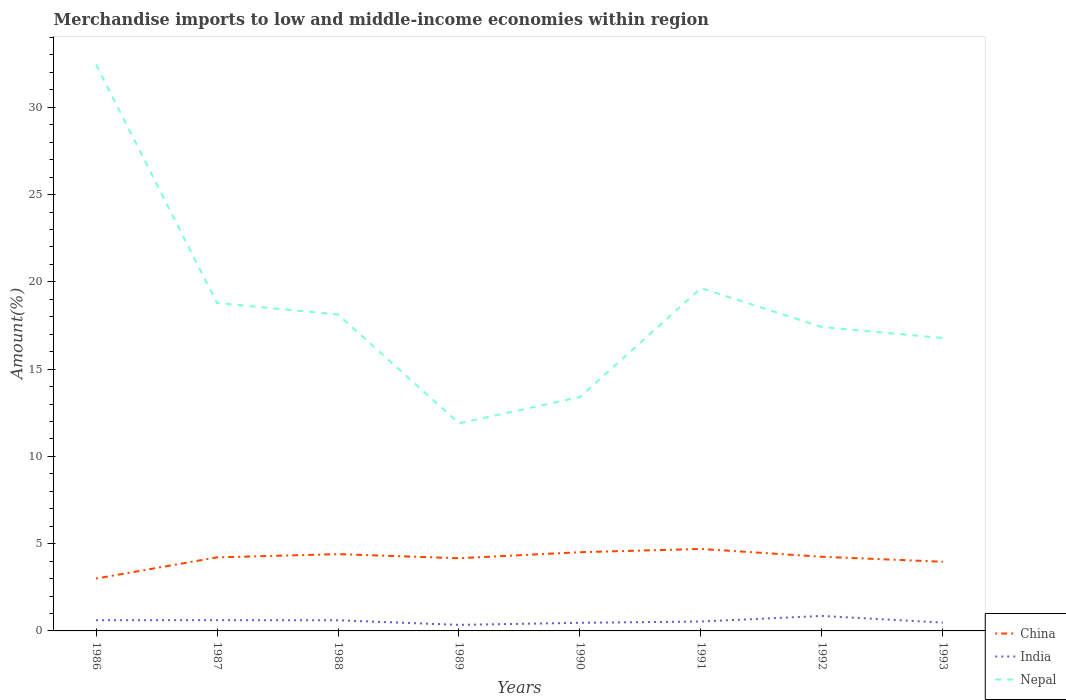Across all years, what is the maximum percentage of amount earned from merchandise imports in China?
Offer a very short reply. 3. What is the total percentage of amount earned from merchandise imports in India in the graph?
Provide a short and direct response. -0. What is the difference between the highest and the second highest percentage of amount earned from merchandise imports in China?
Make the answer very short. 1.7. What is the difference between the highest and the lowest percentage of amount earned from merchandise imports in India?
Offer a terse response. 4. How many years are there in the graph?
Your response must be concise. 8. Are the values on the major ticks of Y-axis written in scientific E-notation?
Ensure brevity in your answer.  No. What is the title of the graph?
Your response must be concise. Merchandise imports to low and middle-income economies within region. What is the label or title of the X-axis?
Your answer should be compact. Years. What is the label or title of the Y-axis?
Make the answer very short. Amount(%). What is the Amount(%) in China in 1986?
Offer a terse response. 3. What is the Amount(%) in India in 1986?
Keep it short and to the point. 0.61. What is the Amount(%) in Nepal in 1986?
Ensure brevity in your answer.  32.45. What is the Amount(%) in China in 1987?
Provide a succinct answer. 4.21. What is the Amount(%) of India in 1987?
Ensure brevity in your answer.  0.62. What is the Amount(%) in Nepal in 1987?
Your response must be concise. 18.79. What is the Amount(%) of China in 1988?
Your answer should be very brief. 4.4. What is the Amount(%) in India in 1988?
Offer a very short reply. 0.61. What is the Amount(%) in Nepal in 1988?
Give a very brief answer. 18.13. What is the Amount(%) in China in 1989?
Your answer should be compact. 4.16. What is the Amount(%) of India in 1989?
Make the answer very short. 0.35. What is the Amount(%) of Nepal in 1989?
Your answer should be very brief. 11.89. What is the Amount(%) in China in 1990?
Keep it short and to the point. 4.51. What is the Amount(%) in India in 1990?
Your answer should be very brief. 0.46. What is the Amount(%) of Nepal in 1990?
Give a very brief answer. 13.4. What is the Amount(%) of China in 1991?
Offer a terse response. 4.7. What is the Amount(%) of India in 1991?
Your answer should be very brief. 0.54. What is the Amount(%) of Nepal in 1991?
Offer a terse response. 19.64. What is the Amount(%) in China in 1992?
Ensure brevity in your answer.  4.25. What is the Amount(%) of India in 1992?
Make the answer very short. 0.86. What is the Amount(%) of Nepal in 1992?
Your answer should be compact. 17.41. What is the Amount(%) in China in 1993?
Your answer should be compact. 3.96. What is the Amount(%) of India in 1993?
Make the answer very short. 0.48. What is the Amount(%) of Nepal in 1993?
Your answer should be compact. 16.78. Across all years, what is the maximum Amount(%) of China?
Offer a terse response. 4.7. Across all years, what is the maximum Amount(%) in India?
Provide a short and direct response. 0.86. Across all years, what is the maximum Amount(%) of Nepal?
Make the answer very short. 32.45. Across all years, what is the minimum Amount(%) of China?
Provide a succinct answer. 3. Across all years, what is the minimum Amount(%) of India?
Give a very brief answer. 0.35. Across all years, what is the minimum Amount(%) of Nepal?
Ensure brevity in your answer.  11.89. What is the total Amount(%) in China in the graph?
Provide a short and direct response. 33.2. What is the total Amount(%) in India in the graph?
Offer a terse response. 4.52. What is the total Amount(%) in Nepal in the graph?
Your answer should be very brief. 148.49. What is the difference between the Amount(%) of China in 1986 and that in 1987?
Your answer should be very brief. -1.21. What is the difference between the Amount(%) in India in 1986 and that in 1987?
Provide a succinct answer. -0. What is the difference between the Amount(%) of Nepal in 1986 and that in 1987?
Your answer should be very brief. 13.66. What is the difference between the Amount(%) in China in 1986 and that in 1988?
Ensure brevity in your answer.  -1.4. What is the difference between the Amount(%) of India in 1986 and that in 1988?
Provide a succinct answer. 0.01. What is the difference between the Amount(%) in Nepal in 1986 and that in 1988?
Ensure brevity in your answer.  14.32. What is the difference between the Amount(%) of China in 1986 and that in 1989?
Offer a very short reply. -1.16. What is the difference between the Amount(%) of India in 1986 and that in 1989?
Your answer should be compact. 0.27. What is the difference between the Amount(%) in Nepal in 1986 and that in 1989?
Make the answer very short. 20.55. What is the difference between the Amount(%) of China in 1986 and that in 1990?
Offer a very short reply. -1.51. What is the difference between the Amount(%) in India in 1986 and that in 1990?
Keep it short and to the point. 0.15. What is the difference between the Amount(%) of Nepal in 1986 and that in 1990?
Give a very brief answer. 19.04. What is the difference between the Amount(%) in China in 1986 and that in 1991?
Your answer should be compact. -1.7. What is the difference between the Amount(%) in India in 1986 and that in 1991?
Keep it short and to the point. 0.07. What is the difference between the Amount(%) in Nepal in 1986 and that in 1991?
Keep it short and to the point. 12.81. What is the difference between the Amount(%) of China in 1986 and that in 1992?
Provide a short and direct response. -1.25. What is the difference between the Amount(%) in India in 1986 and that in 1992?
Give a very brief answer. -0.25. What is the difference between the Amount(%) in Nepal in 1986 and that in 1992?
Ensure brevity in your answer.  15.04. What is the difference between the Amount(%) in China in 1986 and that in 1993?
Offer a very short reply. -0.96. What is the difference between the Amount(%) in India in 1986 and that in 1993?
Ensure brevity in your answer.  0.14. What is the difference between the Amount(%) in Nepal in 1986 and that in 1993?
Offer a very short reply. 15.66. What is the difference between the Amount(%) of China in 1987 and that in 1988?
Your response must be concise. -0.19. What is the difference between the Amount(%) in India in 1987 and that in 1988?
Provide a short and direct response. 0.01. What is the difference between the Amount(%) in Nepal in 1987 and that in 1988?
Offer a very short reply. 0.66. What is the difference between the Amount(%) of China in 1987 and that in 1989?
Offer a very short reply. 0.05. What is the difference between the Amount(%) in India in 1987 and that in 1989?
Provide a short and direct response. 0.27. What is the difference between the Amount(%) of Nepal in 1987 and that in 1989?
Provide a short and direct response. 6.89. What is the difference between the Amount(%) in China in 1987 and that in 1990?
Keep it short and to the point. -0.3. What is the difference between the Amount(%) in India in 1987 and that in 1990?
Ensure brevity in your answer.  0.15. What is the difference between the Amount(%) in Nepal in 1987 and that in 1990?
Your answer should be compact. 5.39. What is the difference between the Amount(%) of China in 1987 and that in 1991?
Offer a very short reply. -0.48. What is the difference between the Amount(%) of India in 1987 and that in 1991?
Your answer should be compact. 0.08. What is the difference between the Amount(%) of Nepal in 1987 and that in 1991?
Your response must be concise. -0.85. What is the difference between the Amount(%) of China in 1987 and that in 1992?
Ensure brevity in your answer.  -0.04. What is the difference between the Amount(%) in India in 1987 and that in 1992?
Offer a terse response. -0.24. What is the difference between the Amount(%) in Nepal in 1987 and that in 1992?
Your answer should be compact. 1.38. What is the difference between the Amount(%) of China in 1987 and that in 1993?
Your answer should be very brief. 0.25. What is the difference between the Amount(%) in India in 1987 and that in 1993?
Your answer should be very brief. 0.14. What is the difference between the Amount(%) of Nepal in 1987 and that in 1993?
Ensure brevity in your answer.  2.01. What is the difference between the Amount(%) of China in 1988 and that in 1989?
Your answer should be very brief. 0.23. What is the difference between the Amount(%) in India in 1988 and that in 1989?
Offer a very short reply. 0.26. What is the difference between the Amount(%) of Nepal in 1988 and that in 1989?
Ensure brevity in your answer.  6.23. What is the difference between the Amount(%) of China in 1988 and that in 1990?
Offer a very short reply. -0.11. What is the difference between the Amount(%) of India in 1988 and that in 1990?
Give a very brief answer. 0.14. What is the difference between the Amount(%) of Nepal in 1988 and that in 1990?
Ensure brevity in your answer.  4.73. What is the difference between the Amount(%) of China in 1988 and that in 1991?
Keep it short and to the point. -0.3. What is the difference between the Amount(%) in India in 1988 and that in 1991?
Make the answer very short. 0.07. What is the difference between the Amount(%) of Nepal in 1988 and that in 1991?
Provide a succinct answer. -1.51. What is the difference between the Amount(%) in China in 1988 and that in 1992?
Your response must be concise. 0.15. What is the difference between the Amount(%) in India in 1988 and that in 1992?
Give a very brief answer. -0.25. What is the difference between the Amount(%) in Nepal in 1988 and that in 1992?
Offer a very short reply. 0.72. What is the difference between the Amount(%) of China in 1988 and that in 1993?
Your answer should be compact. 0.44. What is the difference between the Amount(%) in India in 1988 and that in 1993?
Make the answer very short. 0.13. What is the difference between the Amount(%) in Nepal in 1988 and that in 1993?
Ensure brevity in your answer.  1.35. What is the difference between the Amount(%) of China in 1989 and that in 1990?
Offer a terse response. -0.35. What is the difference between the Amount(%) in India in 1989 and that in 1990?
Provide a short and direct response. -0.12. What is the difference between the Amount(%) in Nepal in 1989 and that in 1990?
Your response must be concise. -1.51. What is the difference between the Amount(%) in China in 1989 and that in 1991?
Make the answer very short. -0.53. What is the difference between the Amount(%) in India in 1989 and that in 1991?
Give a very brief answer. -0.19. What is the difference between the Amount(%) in Nepal in 1989 and that in 1991?
Offer a terse response. -7.75. What is the difference between the Amount(%) of China in 1989 and that in 1992?
Your answer should be compact. -0.09. What is the difference between the Amount(%) in India in 1989 and that in 1992?
Provide a short and direct response. -0.51. What is the difference between the Amount(%) of Nepal in 1989 and that in 1992?
Give a very brief answer. -5.52. What is the difference between the Amount(%) in China in 1989 and that in 1993?
Ensure brevity in your answer.  0.2. What is the difference between the Amount(%) in India in 1989 and that in 1993?
Keep it short and to the point. -0.13. What is the difference between the Amount(%) of Nepal in 1989 and that in 1993?
Your answer should be compact. -4.89. What is the difference between the Amount(%) in China in 1990 and that in 1991?
Your answer should be very brief. -0.19. What is the difference between the Amount(%) in India in 1990 and that in 1991?
Provide a short and direct response. -0.08. What is the difference between the Amount(%) in Nepal in 1990 and that in 1991?
Make the answer very short. -6.24. What is the difference between the Amount(%) in China in 1990 and that in 1992?
Provide a succinct answer. 0.26. What is the difference between the Amount(%) of India in 1990 and that in 1992?
Ensure brevity in your answer.  -0.39. What is the difference between the Amount(%) of Nepal in 1990 and that in 1992?
Your response must be concise. -4.01. What is the difference between the Amount(%) of China in 1990 and that in 1993?
Provide a succinct answer. 0.55. What is the difference between the Amount(%) of India in 1990 and that in 1993?
Offer a terse response. -0.01. What is the difference between the Amount(%) in Nepal in 1990 and that in 1993?
Your answer should be compact. -3.38. What is the difference between the Amount(%) in China in 1991 and that in 1992?
Give a very brief answer. 0.45. What is the difference between the Amount(%) in India in 1991 and that in 1992?
Your answer should be very brief. -0.32. What is the difference between the Amount(%) of Nepal in 1991 and that in 1992?
Provide a short and direct response. 2.23. What is the difference between the Amount(%) in China in 1991 and that in 1993?
Make the answer very short. 0.73. What is the difference between the Amount(%) in India in 1991 and that in 1993?
Your answer should be very brief. 0.06. What is the difference between the Amount(%) in Nepal in 1991 and that in 1993?
Your answer should be very brief. 2.86. What is the difference between the Amount(%) of China in 1992 and that in 1993?
Provide a short and direct response. 0.29. What is the difference between the Amount(%) of India in 1992 and that in 1993?
Make the answer very short. 0.38. What is the difference between the Amount(%) in Nepal in 1992 and that in 1993?
Your answer should be very brief. 0.63. What is the difference between the Amount(%) of China in 1986 and the Amount(%) of India in 1987?
Offer a terse response. 2.39. What is the difference between the Amount(%) in China in 1986 and the Amount(%) in Nepal in 1987?
Your answer should be compact. -15.79. What is the difference between the Amount(%) of India in 1986 and the Amount(%) of Nepal in 1987?
Offer a very short reply. -18.17. What is the difference between the Amount(%) of China in 1986 and the Amount(%) of India in 1988?
Offer a very short reply. 2.39. What is the difference between the Amount(%) in China in 1986 and the Amount(%) in Nepal in 1988?
Keep it short and to the point. -15.13. What is the difference between the Amount(%) in India in 1986 and the Amount(%) in Nepal in 1988?
Your answer should be compact. -17.51. What is the difference between the Amount(%) in China in 1986 and the Amount(%) in India in 1989?
Provide a succinct answer. 2.65. What is the difference between the Amount(%) of China in 1986 and the Amount(%) of Nepal in 1989?
Make the answer very short. -8.89. What is the difference between the Amount(%) of India in 1986 and the Amount(%) of Nepal in 1989?
Your response must be concise. -11.28. What is the difference between the Amount(%) in China in 1986 and the Amount(%) in India in 1990?
Your response must be concise. 2.54. What is the difference between the Amount(%) in China in 1986 and the Amount(%) in Nepal in 1990?
Give a very brief answer. -10.4. What is the difference between the Amount(%) in India in 1986 and the Amount(%) in Nepal in 1990?
Your answer should be very brief. -12.79. What is the difference between the Amount(%) in China in 1986 and the Amount(%) in India in 1991?
Give a very brief answer. 2.46. What is the difference between the Amount(%) in China in 1986 and the Amount(%) in Nepal in 1991?
Your response must be concise. -16.64. What is the difference between the Amount(%) of India in 1986 and the Amount(%) of Nepal in 1991?
Provide a succinct answer. -19.03. What is the difference between the Amount(%) of China in 1986 and the Amount(%) of India in 1992?
Give a very brief answer. 2.14. What is the difference between the Amount(%) in China in 1986 and the Amount(%) in Nepal in 1992?
Offer a very short reply. -14.41. What is the difference between the Amount(%) of India in 1986 and the Amount(%) of Nepal in 1992?
Offer a terse response. -16.8. What is the difference between the Amount(%) in China in 1986 and the Amount(%) in India in 1993?
Your response must be concise. 2.52. What is the difference between the Amount(%) in China in 1986 and the Amount(%) in Nepal in 1993?
Offer a very short reply. -13.78. What is the difference between the Amount(%) in India in 1986 and the Amount(%) in Nepal in 1993?
Provide a short and direct response. -16.17. What is the difference between the Amount(%) in China in 1987 and the Amount(%) in India in 1988?
Offer a very short reply. 3.61. What is the difference between the Amount(%) of China in 1987 and the Amount(%) of Nepal in 1988?
Provide a succinct answer. -13.91. What is the difference between the Amount(%) of India in 1987 and the Amount(%) of Nepal in 1988?
Keep it short and to the point. -17.51. What is the difference between the Amount(%) in China in 1987 and the Amount(%) in India in 1989?
Give a very brief answer. 3.87. What is the difference between the Amount(%) in China in 1987 and the Amount(%) in Nepal in 1989?
Make the answer very short. -7.68. What is the difference between the Amount(%) of India in 1987 and the Amount(%) of Nepal in 1989?
Give a very brief answer. -11.28. What is the difference between the Amount(%) in China in 1987 and the Amount(%) in India in 1990?
Keep it short and to the point. 3.75. What is the difference between the Amount(%) of China in 1987 and the Amount(%) of Nepal in 1990?
Make the answer very short. -9.19. What is the difference between the Amount(%) of India in 1987 and the Amount(%) of Nepal in 1990?
Keep it short and to the point. -12.79. What is the difference between the Amount(%) in China in 1987 and the Amount(%) in India in 1991?
Provide a short and direct response. 3.67. What is the difference between the Amount(%) in China in 1987 and the Amount(%) in Nepal in 1991?
Your response must be concise. -15.43. What is the difference between the Amount(%) of India in 1987 and the Amount(%) of Nepal in 1991?
Your answer should be compact. -19.03. What is the difference between the Amount(%) of China in 1987 and the Amount(%) of India in 1992?
Your answer should be very brief. 3.36. What is the difference between the Amount(%) of China in 1987 and the Amount(%) of Nepal in 1992?
Your response must be concise. -13.2. What is the difference between the Amount(%) in India in 1987 and the Amount(%) in Nepal in 1992?
Offer a terse response. -16.8. What is the difference between the Amount(%) in China in 1987 and the Amount(%) in India in 1993?
Your answer should be compact. 3.74. What is the difference between the Amount(%) in China in 1987 and the Amount(%) in Nepal in 1993?
Your answer should be compact. -12.57. What is the difference between the Amount(%) in India in 1987 and the Amount(%) in Nepal in 1993?
Make the answer very short. -16.17. What is the difference between the Amount(%) in China in 1988 and the Amount(%) in India in 1989?
Your response must be concise. 4.05. What is the difference between the Amount(%) in China in 1988 and the Amount(%) in Nepal in 1989?
Give a very brief answer. -7.5. What is the difference between the Amount(%) in India in 1988 and the Amount(%) in Nepal in 1989?
Provide a succinct answer. -11.29. What is the difference between the Amount(%) in China in 1988 and the Amount(%) in India in 1990?
Ensure brevity in your answer.  3.93. What is the difference between the Amount(%) in China in 1988 and the Amount(%) in Nepal in 1990?
Your answer should be very brief. -9. What is the difference between the Amount(%) of India in 1988 and the Amount(%) of Nepal in 1990?
Your answer should be compact. -12.79. What is the difference between the Amount(%) in China in 1988 and the Amount(%) in India in 1991?
Your answer should be very brief. 3.86. What is the difference between the Amount(%) of China in 1988 and the Amount(%) of Nepal in 1991?
Provide a short and direct response. -15.24. What is the difference between the Amount(%) of India in 1988 and the Amount(%) of Nepal in 1991?
Offer a very short reply. -19.03. What is the difference between the Amount(%) of China in 1988 and the Amount(%) of India in 1992?
Offer a very short reply. 3.54. What is the difference between the Amount(%) of China in 1988 and the Amount(%) of Nepal in 1992?
Keep it short and to the point. -13.01. What is the difference between the Amount(%) of India in 1988 and the Amount(%) of Nepal in 1992?
Offer a very short reply. -16.8. What is the difference between the Amount(%) in China in 1988 and the Amount(%) in India in 1993?
Provide a short and direct response. 3.92. What is the difference between the Amount(%) of China in 1988 and the Amount(%) of Nepal in 1993?
Provide a succinct answer. -12.38. What is the difference between the Amount(%) in India in 1988 and the Amount(%) in Nepal in 1993?
Make the answer very short. -16.17. What is the difference between the Amount(%) in China in 1989 and the Amount(%) in India in 1990?
Ensure brevity in your answer.  3.7. What is the difference between the Amount(%) of China in 1989 and the Amount(%) of Nepal in 1990?
Provide a succinct answer. -9.24. What is the difference between the Amount(%) in India in 1989 and the Amount(%) in Nepal in 1990?
Provide a succinct answer. -13.05. What is the difference between the Amount(%) in China in 1989 and the Amount(%) in India in 1991?
Make the answer very short. 3.62. What is the difference between the Amount(%) of China in 1989 and the Amount(%) of Nepal in 1991?
Offer a terse response. -15.48. What is the difference between the Amount(%) in India in 1989 and the Amount(%) in Nepal in 1991?
Provide a succinct answer. -19.29. What is the difference between the Amount(%) of China in 1989 and the Amount(%) of India in 1992?
Make the answer very short. 3.31. What is the difference between the Amount(%) in China in 1989 and the Amount(%) in Nepal in 1992?
Make the answer very short. -13.25. What is the difference between the Amount(%) of India in 1989 and the Amount(%) of Nepal in 1992?
Offer a terse response. -17.06. What is the difference between the Amount(%) in China in 1989 and the Amount(%) in India in 1993?
Your answer should be very brief. 3.69. What is the difference between the Amount(%) in China in 1989 and the Amount(%) in Nepal in 1993?
Your answer should be compact. -12.62. What is the difference between the Amount(%) of India in 1989 and the Amount(%) of Nepal in 1993?
Your answer should be compact. -16.43. What is the difference between the Amount(%) in China in 1990 and the Amount(%) in India in 1991?
Offer a very short reply. 3.97. What is the difference between the Amount(%) of China in 1990 and the Amount(%) of Nepal in 1991?
Offer a very short reply. -15.13. What is the difference between the Amount(%) of India in 1990 and the Amount(%) of Nepal in 1991?
Offer a terse response. -19.18. What is the difference between the Amount(%) of China in 1990 and the Amount(%) of India in 1992?
Make the answer very short. 3.65. What is the difference between the Amount(%) in China in 1990 and the Amount(%) in Nepal in 1992?
Your response must be concise. -12.9. What is the difference between the Amount(%) in India in 1990 and the Amount(%) in Nepal in 1992?
Give a very brief answer. -16.95. What is the difference between the Amount(%) of China in 1990 and the Amount(%) of India in 1993?
Keep it short and to the point. 4.03. What is the difference between the Amount(%) of China in 1990 and the Amount(%) of Nepal in 1993?
Your answer should be compact. -12.27. What is the difference between the Amount(%) in India in 1990 and the Amount(%) in Nepal in 1993?
Make the answer very short. -16.32. What is the difference between the Amount(%) of China in 1991 and the Amount(%) of India in 1992?
Provide a succinct answer. 3.84. What is the difference between the Amount(%) of China in 1991 and the Amount(%) of Nepal in 1992?
Make the answer very short. -12.71. What is the difference between the Amount(%) of India in 1991 and the Amount(%) of Nepal in 1992?
Your answer should be very brief. -16.87. What is the difference between the Amount(%) of China in 1991 and the Amount(%) of India in 1993?
Your answer should be compact. 4.22. What is the difference between the Amount(%) of China in 1991 and the Amount(%) of Nepal in 1993?
Your answer should be very brief. -12.08. What is the difference between the Amount(%) of India in 1991 and the Amount(%) of Nepal in 1993?
Offer a terse response. -16.24. What is the difference between the Amount(%) in China in 1992 and the Amount(%) in India in 1993?
Ensure brevity in your answer.  3.77. What is the difference between the Amount(%) in China in 1992 and the Amount(%) in Nepal in 1993?
Give a very brief answer. -12.53. What is the difference between the Amount(%) in India in 1992 and the Amount(%) in Nepal in 1993?
Offer a very short reply. -15.92. What is the average Amount(%) in China per year?
Your answer should be compact. 4.15. What is the average Amount(%) in India per year?
Offer a terse response. 0.57. What is the average Amount(%) in Nepal per year?
Offer a very short reply. 18.56. In the year 1986, what is the difference between the Amount(%) of China and Amount(%) of India?
Provide a short and direct response. 2.39. In the year 1986, what is the difference between the Amount(%) in China and Amount(%) in Nepal?
Your answer should be compact. -29.44. In the year 1986, what is the difference between the Amount(%) in India and Amount(%) in Nepal?
Provide a short and direct response. -31.83. In the year 1987, what is the difference between the Amount(%) of China and Amount(%) of India?
Your response must be concise. 3.6. In the year 1987, what is the difference between the Amount(%) in China and Amount(%) in Nepal?
Provide a succinct answer. -14.57. In the year 1987, what is the difference between the Amount(%) in India and Amount(%) in Nepal?
Offer a terse response. -18.17. In the year 1988, what is the difference between the Amount(%) in China and Amount(%) in India?
Your answer should be compact. 3.79. In the year 1988, what is the difference between the Amount(%) in China and Amount(%) in Nepal?
Keep it short and to the point. -13.73. In the year 1988, what is the difference between the Amount(%) in India and Amount(%) in Nepal?
Offer a terse response. -17.52. In the year 1989, what is the difference between the Amount(%) of China and Amount(%) of India?
Offer a very short reply. 3.82. In the year 1989, what is the difference between the Amount(%) of China and Amount(%) of Nepal?
Your answer should be compact. -7.73. In the year 1989, what is the difference between the Amount(%) in India and Amount(%) in Nepal?
Provide a succinct answer. -11.55. In the year 1990, what is the difference between the Amount(%) of China and Amount(%) of India?
Make the answer very short. 4.05. In the year 1990, what is the difference between the Amount(%) of China and Amount(%) of Nepal?
Give a very brief answer. -8.89. In the year 1990, what is the difference between the Amount(%) of India and Amount(%) of Nepal?
Your response must be concise. -12.94. In the year 1991, what is the difference between the Amount(%) of China and Amount(%) of India?
Your response must be concise. 4.16. In the year 1991, what is the difference between the Amount(%) of China and Amount(%) of Nepal?
Provide a succinct answer. -14.94. In the year 1991, what is the difference between the Amount(%) in India and Amount(%) in Nepal?
Make the answer very short. -19.1. In the year 1992, what is the difference between the Amount(%) of China and Amount(%) of India?
Your response must be concise. 3.39. In the year 1992, what is the difference between the Amount(%) of China and Amount(%) of Nepal?
Give a very brief answer. -13.16. In the year 1992, what is the difference between the Amount(%) of India and Amount(%) of Nepal?
Your response must be concise. -16.55. In the year 1993, what is the difference between the Amount(%) in China and Amount(%) in India?
Offer a very short reply. 3.49. In the year 1993, what is the difference between the Amount(%) of China and Amount(%) of Nepal?
Make the answer very short. -12.82. In the year 1993, what is the difference between the Amount(%) in India and Amount(%) in Nepal?
Keep it short and to the point. -16.31. What is the ratio of the Amount(%) in China in 1986 to that in 1987?
Provide a succinct answer. 0.71. What is the ratio of the Amount(%) in Nepal in 1986 to that in 1987?
Give a very brief answer. 1.73. What is the ratio of the Amount(%) in China in 1986 to that in 1988?
Your answer should be compact. 0.68. What is the ratio of the Amount(%) of India in 1986 to that in 1988?
Make the answer very short. 1.01. What is the ratio of the Amount(%) in Nepal in 1986 to that in 1988?
Your answer should be compact. 1.79. What is the ratio of the Amount(%) of China in 1986 to that in 1989?
Give a very brief answer. 0.72. What is the ratio of the Amount(%) of India in 1986 to that in 1989?
Make the answer very short. 1.77. What is the ratio of the Amount(%) in Nepal in 1986 to that in 1989?
Keep it short and to the point. 2.73. What is the ratio of the Amount(%) of China in 1986 to that in 1990?
Make the answer very short. 0.67. What is the ratio of the Amount(%) in India in 1986 to that in 1990?
Your response must be concise. 1.32. What is the ratio of the Amount(%) of Nepal in 1986 to that in 1990?
Your response must be concise. 2.42. What is the ratio of the Amount(%) of China in 1986 to that in 1991?
Offer a terse response. 0.64. What is the ratio of the Amount(%) in India in 1986 to that in 1991?
Offer a very short reply. 1.14. What is the ratio of the Amount(%) in Nepal in 1986 to that in 1991?
Ensure brevity in your answer.  1.65. What is the ratio of the Amount(%) in China in 1986 to that in 1992?
Keep it short and to the point. 0.71. What is the ratio of the Amount(%) of India in 1986 to that in 1992?
Keep it short and to the point. 0.71. What is the ratio of the Amount(%) of Nepal in 1986 to that in 1992?
Provide a short and direct response. 1.86. What is the ratio of the Amount(%) in China in 1986 to that in 1993?
Provide a succinct answer. 0.76. What is the ratio of the Amount(%) in India in 1986 to that in 1993?
Offer a very short reply. 1.29. What is the ratio of the Amount(%) of Nepal in 1986 to that in 1993?
Ensure brevity in your answer.  1.93. What is the ratio of the Amount(%) in China in 1987 to that in 1988?
Your answer should be very brief. 0.96. What is the ratio of the Amount(%) of India in 1987 to that in 1988?
Your answer should be compact. 1.01. What is the ratio of the Amount(%) of Nepal in 1987 to that in 1988?
Your response must be concise. 1.04. What is the ratio of the Amount(%) in China in 1987 to that in 1989?
Ensure brevity in your answer.  1.01. What is the ratio of the Amount(%) of India in 1987 to that in 1989?
Give a very brief answer. 1.78. What is the ratio of the Amount(%) in Nepal in 1987 to that in 1989?
Provide a short and direct response. 1.58. What is the ratio of the Amount(%) of China in 1987 to that in 1990?
Make the answer very short. 0.93. What is the ratio of the Amount(%) of India in 1987 to that in 1990?
Ensure brevity in your answer.  1.33. What is the ratio of the Amount(%) in Nepal in 1987 to that in 1990?
Provide a succinct answer. 1.4. What is the ratio of the Amount(%) in China in 1987 to that in 1991?
Your response must be concise. 0.9. What is the ratio of the Amount(%) of India in 1987 to that in 1991?
Ensure brevity in your answer.  1.14. What is the ratio of the Amount(%) of Nepal in 1987 to that in 1991?
Offer a very short reply. 0.96. What is the ratio of the Amount(%) in India in 1987 to that in 1992?
Your answer should be very brief. 0.72. What is the ratio of the Amount(%) in Nepal in 1987 to that in 1992?
Your answer should be compact. 1.08. What is the ratio of the Amount(%) of China in 1987 to that in 1993?
Keep it short and to the point. 1.06. What is the ratio of the Amount(%) of India in 1987 to that in 1993?
Your answer should be very brief. 1.29. What is the ratio of the Amount(%) in Nepal in 1987 to that in 1993?
Your answer should be compact. 1.12. What is the ratio of the Amount(%) in China in 1988 to that in 1989?
Your answer should be compact. 1.06. What is the ratio of the Amount(%) in India in 1988 to that in 1989?
Your response must be concise. 1.76. What is the ratio of the Amount(%) in Nepal in 1988 to that in 1989?
Your answer should be very brief. 1.52. What is the ratio of the Amount(%) in China in 1988 to that in 1990?
Provide a short and direct response. 0.98. What is the ratio of the Amount(%) in India in 1988 to that in 1990?
Provide a succinct answer. 1.31. What is the ratio of the Amount(%) in Nepal in 1988 to that in 1990?
Give a very brief answer. 1.35. What is the ratio of the Amount(%) in China in 1988 to that in 1991?
Your answer should be very brief. 0.94. What is the ratio of the Amount(%) of India in 1988 to that in 1991?
Keep it short and to the point. 1.13. What is the ratio of the Amount(%) in Nepal in 1988 to that in 1991?
Make the answer very short. 0.92. What is the ratio of the Amount(%) in China in 1988 to that in 1992?
Your response must be concise. 1.04. What is the ratio of the Amount(%) in India in 1988 to that in 1992?
Your answer should be very brief. 0.71. What is the ratio of the Amount(%) in Nepal in 1988 to that in 1992?
Offer a very short reply. 1.04. What is the ratio of the Amount(%) in China in 1988 to that in 1993?
Keep it short and to the point. 1.11. What is the ratio of the Amount(%) in India in 1988 to that in 1993?
Your response must be concise. 1.28. What is the ratio of the Amount(%) of Nepal in 1988 to that in 1993?
Offer a terse response. 1.08. What is the ratio of the Amount(%) in China in 1989 to that in 1990?
Keep it short and to the point. 0.92. What is the ratio of the Amount(%) in India in 1989 to that in 1990?
Offer a very short reply. 0.75. What is the ratio of the Amount(%) of Nepal in 1989 to that in 1990?
Your answer should be very brief. 0.89. What is the ratio of the Amount(%) in China in 1989 to that in 1991?
Offer a very short reply. 0.89. What is the ratio of the Amount(%) in India in 1989 to that in 1991?
Your answer should be compact. 0.64. What is the ratio of the Amount(%) in Nepal in 1989 to that in 1991?
Give a very brief answer. 0.61. What is the ratio of the Amount(%) of China in 1989 to that in 1992?
Provide a succinct answer. 0.98. What is the ratio of the Amount(%) in India in 1989 to that in 1992?
Make the answer very short. 0.4. What is the ratio of the Amount(%) in Nepal in 1989 to that in 1992?
Ensure brevity in your answer.  0.68. What is the ratio of the Amount(%) in China in 1989 to that in 1993?
Provide a succinct answer. 1.05. What is the ratio of the Amount(%) in India in 1989 to that in 1993?
Give a very brief answer. 0.73. What is the ratio of the Amount(%) in Nepal in 1989 to that in 1993?
Keep it short and to the point. 0.71. What is the ratio of the Amount(%) in China in 1990 to that in 1991?
Make the answer very short. 0.96. What is the ratio of the Amount(%) of India in 1990 to that in 1991?
Your answer should be very brief. 0.86. What is the ratio of the Amount(%) in Nepal in 1990 to that in 1991?
Give a very brief answer. 0.68. What is the ratio of the Amount(%) of China in 1990 to that in 1992?
Your answer should be compact. 1.06. What is the ratio of the Amount(%) of India in 1990 to that in 1992?
Make the answer very short. 0.54. What is the ratio of the Amount(%) in Nepal in 1990 to that in 1992?
Your answer should be very brief. 0.77. What is the ratio of the Amount(%) in China in 1990 to that in 1993?
Offer a very short reply. 1.14. What is the ratio of the Amount(%) in India in 1990 to that in 1993?
Provide a short and direct response. 0.97. What is the ratio of the Amount(%) in Nepal in 1990 to that in 1993?
Your answer should be very brief. 0.8. What is the ratio of the Amount(%) of China in 1991 to that in 1992?
Offer a terse response. 1.11. What is the ratio of the Amount(%) of India in 1991 to that in 1992?
Your answer should be very brief. 0.63. What is the ratio of the Amount(%) in Nepal in 1991 to that in 1992?
Ensure brevity in your answer.  1.13. What is the ratio of the Amount(%) in China in 1991 to that in 1993?
Ensure brevity in your answer.  1.19. What is the ratio of the Amount(%) of India in 1991 to that in 1993?
Your response must be concise. 1.13. What is the ratio of the Amount(%) of Nepal in 1991 to that in 1993?
Make the answer very short. 1.17. What is the ratio of the Amount(%) in China in 1992 to that in 1993?
Your response must be concise. 1.07. What is the ratio of the Amount(%) of India in 1992 to that in 1993?
Provide a succinct answer. 1.8. What is the ratio of the Amount(%) in Nepal in 1992 to that in 1993?
Offer a terse response. 1.04. What is the difference between the highest and the second highest Amount(%) of China?
Provide a succinct answer. 0.19. What is the difference between the highest and the second highest Amount(%) of India?
Your answer should be very brief. 0.24. What is the difference between the highest and the second highest Amount(%) of Nepal?
Give a very brief answer. 12.81. What is the difference between the highest and the lowest Amount(%) of China?
Provide a short and direct response. 1.7. What is the difference between the highest and the lowest Amount(%) of India?
Your answer should be compact. 0.51. What is the difference between the highest and the lowest Amount(%) of Nepal?
Provide a short and direct response. 20.55. 